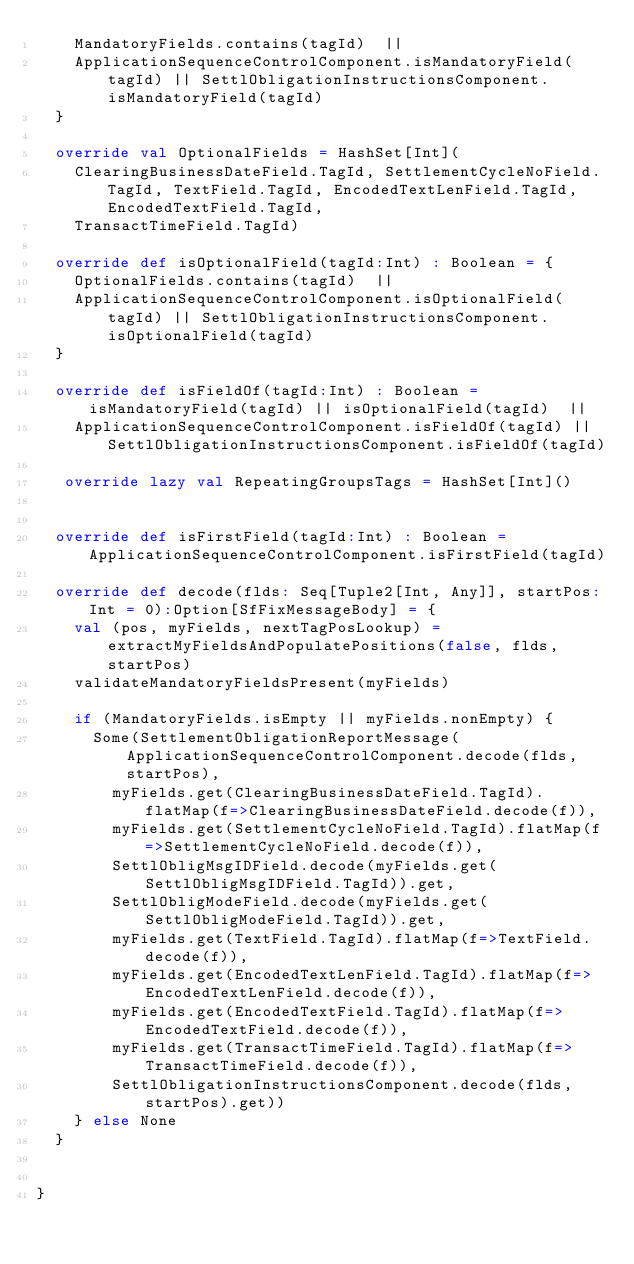Convert code to text. <code><loc_0><loc_0><loc_500><loc_500><_Scala_>    MandatoryFields.contains(tagId)  || 
    ApplicationSequenceControlComponent.isMandatoryField(tagId) || SettlObligationInstructionsComponent.isMandatoryField(tagId)
  }

  override val OptionalFields = HashSet[Int](
    ClearingBusinessDateField.TagId, SettlementCycleNoField.TagId, TextField.TagId, EncodedTextLenField.TagId, EncodedTextField.TagId, 
    TransactTimeField.TagId)

  override def isOptionalField(tagId:Int) : Boolean = {
    OptionalFields.contains(tagId)  || 
    ApplicationSequenceControlComponent.isOptionalField(tagId) || SettlObligationInstructionsComponent.isOptionalField(tagId)
  }

  override def isFieldOf(tagId:Int) : Boolean = isMandatoryField(tagId) || isOptionalField(tagId)  || 
    ApplicationSequenceControlComponent.isFieldOf(tagId) || SettlObligationInstructionsComponent.isFieldOf(tagId)

   override lazy val RepeatingGroupsTags = HashSet[Int]()
  
      
  override def isFirstField(tagId:Int) : Boolean = ApplicationSequenceControlComponent.isFirstField(tagId) 

  override def decode(flds: Seq[Tuple2[Int, Any]], startPos:Int = 0):Option[SfFixMessageBody] = {
    val (pos, myFields, nextTagPosLookup) = extractMyFieldsAndPopulatePositions(false, flds, startPos)
    validateMandatoryFieldsPresent(myFields)

    if (MandatoryFields.isEmpty || myFields.nonEmpty) {
      Some(SettlementObligationReportMessage(ApplicationSequenceControlComponent.decode(flds, startPos),
        myFields.get(ClearingBusinessDateField.TagId).flatMap(f=>ClearingBusinessDateField.decode(f)),
        myFields.get(SettlementCycleNoField.TagId).flatMap(f=>SettlementCycleNoField.decode(f)),
        SettlObligMsgIDField.decode(myFields.get(SettlObligMsgIDField.TagId)).get,
        SettlObligModeField.decode(myFields.get(SettlObligModeField.TagId)).get,
        myFields.get(TextField.TagId).flatMap(f=>TextField.decode(f)),
        myFields.get(EncodedTextLenField.TagId).flatMap(f=>EncodedTextLenField.decode(f)),
        myFields.get(EncodedTextField.TagId).flatMap(f=>EncodedTextField.decode(f)),
        myFields.get(TransactTimeField.TagId).flatMap(f=>TransactTimeField.decode(f)),
        SettlObligationInstructionsComponent.decode(flds, startPos).get))
    } else None
  }

    
}
     </code> 